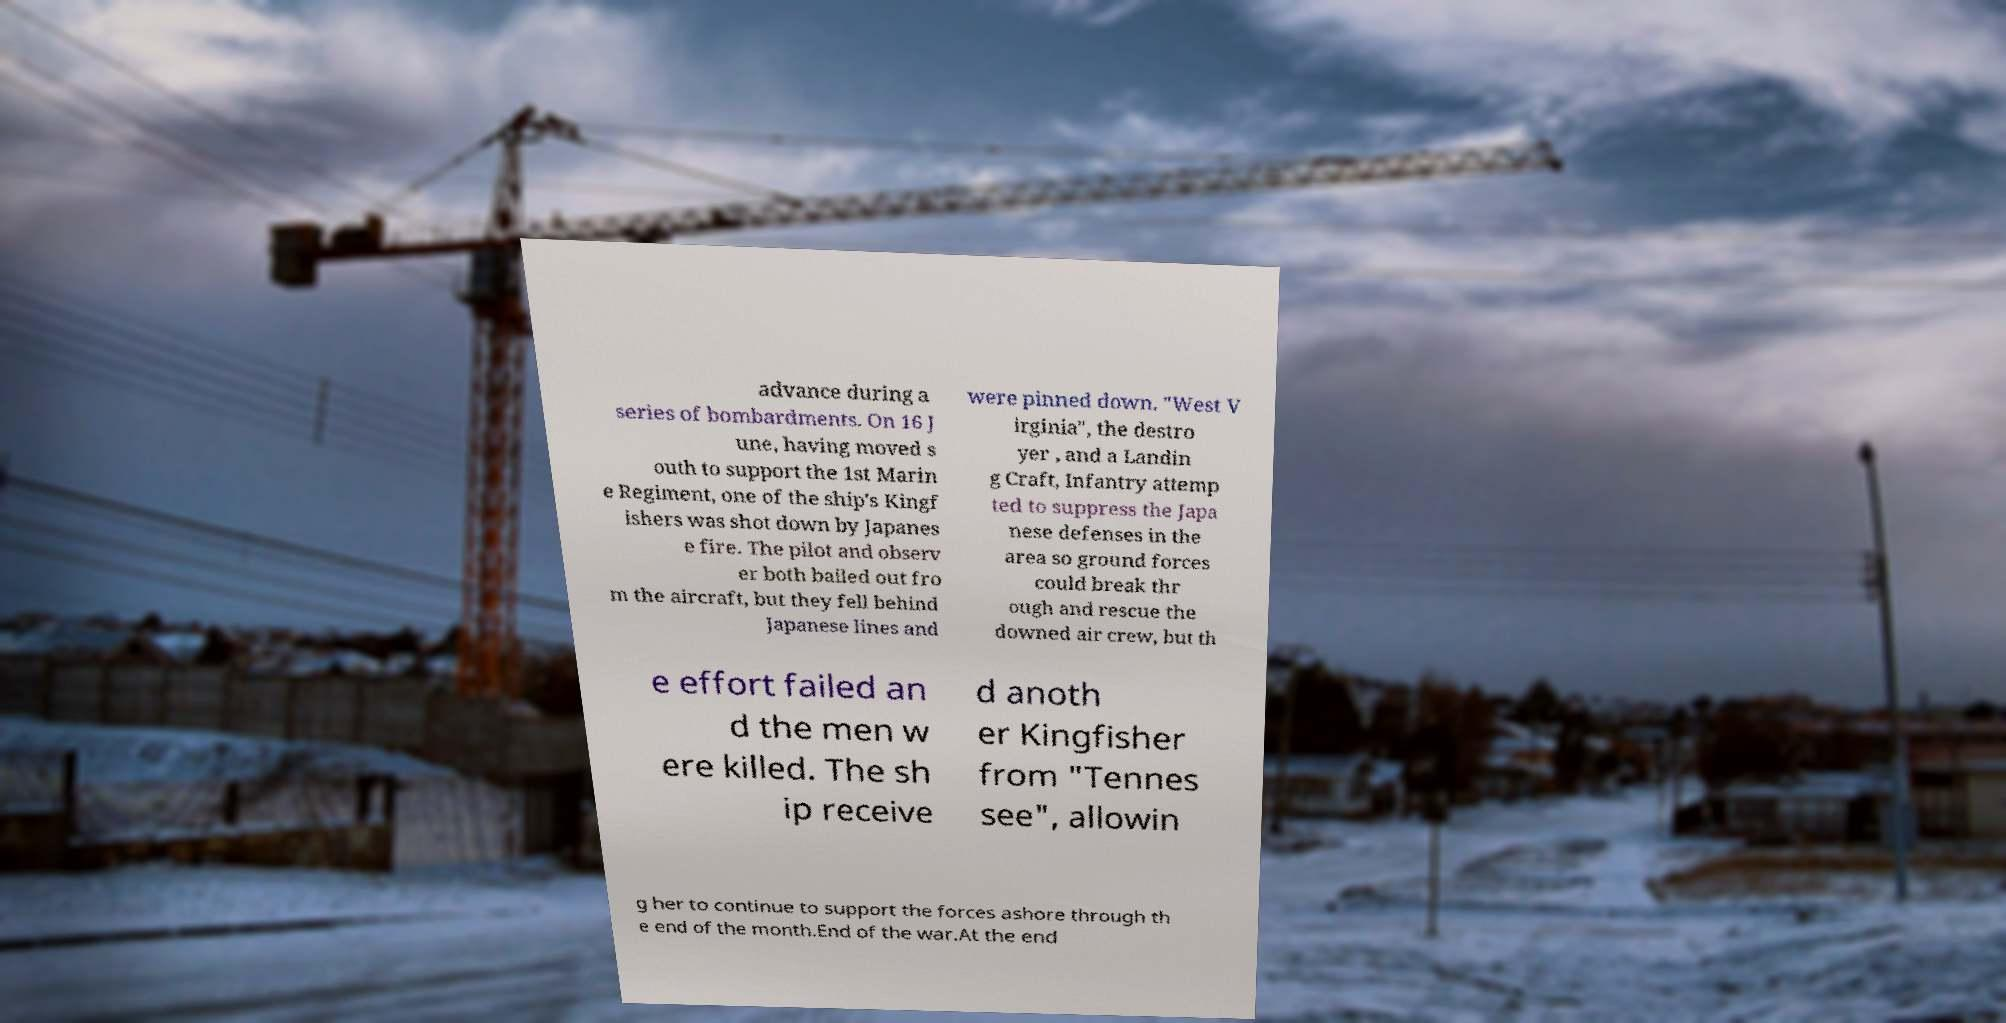For documentation purposes, I need the text within this image transcribed. Could you provide that? advance during a series of bombardments. On 16 J une, having moved s outh to support the 1st Marin e Regiment, one of the ship's Kingf ishers was shot down by Japanes e fire. The pilot and observ er both bailed out fro m the aircraft, but they fell behind Japanese lines and were pinned down. "West V irginia", the destro yer , and a Landin g Craft, Infantry attemp ted to suppress the Japa nese defenses in the area so ground forces could break thr ough and rescue the downed air crew, but th e effort failed an d the men w ere killed. The sh ip receive d anoth er Kingfisher from "Tennes see", allowin g her to continue to support the forces ashore through th e end of the month.End of the war.At the end 